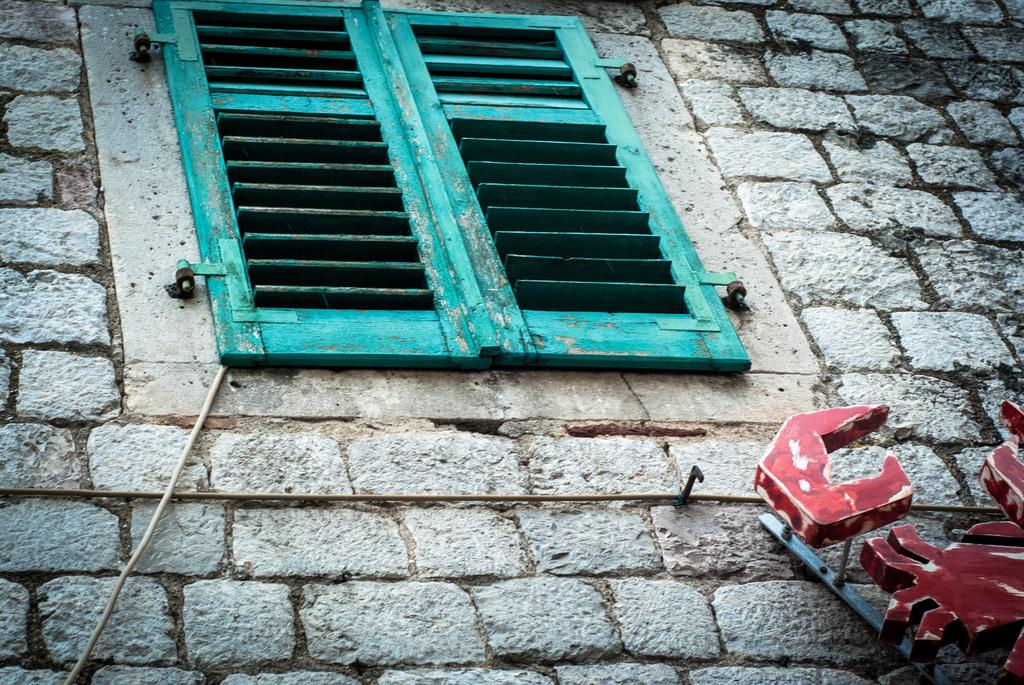What type of material is used to construct the wall in the image? The wall in the image is made of bricks. What feature can be seen on the wall? There is a wooden window on the wall. Can you describe the object that is going through the window? A wire is going through the window. What is attached to the wall in the image? There is an object on the wall. How does the light from the tank affect the limit of the object on the wall? There is no light or tank present in the image, so this question cannot be answered based on the provided facts. 